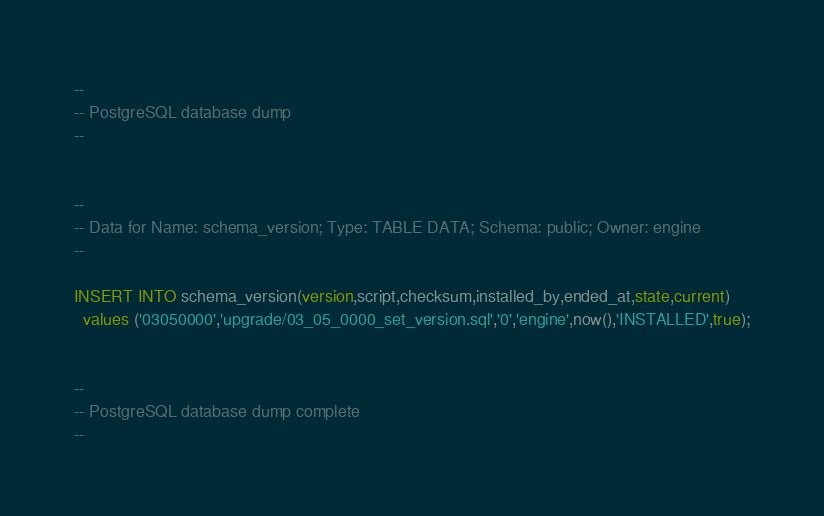Convert code to text. <code><loc_0><loc_0><loc_500><loc_500><_SQL_>--
-- PostgreSQL database dump
--


--
-- Data for Name: schema_version; Type: TABLE DATA; Schema: public; Owner: engine
--

INSERT INTO schema_version(version,script,checksum,installed_by,ended_at,state,current)
  values ('03050000','upgrade/03_05_0000_set_version.sql','0','engine',now(),'INSTALLED',true);


--
-- PostgreSQL database dump complete
--

</code> 